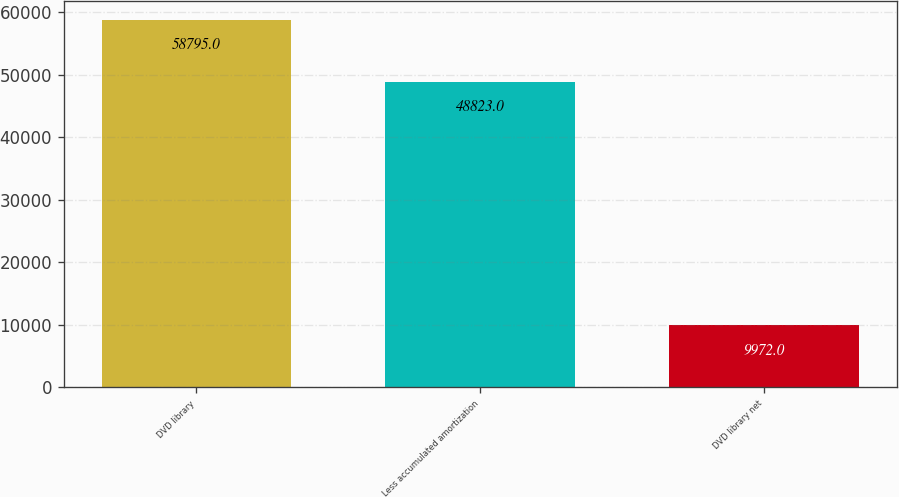Convert chart to OTSL. <chart><loc_0><loc_0><loc_500><loc_500><bar_chart><fcel>DVD library<fcel>Less accumulated amortization<fcel>DVD library net<nl><fcel>58795<fcel>48823<fcel>9972<nl></chart> 